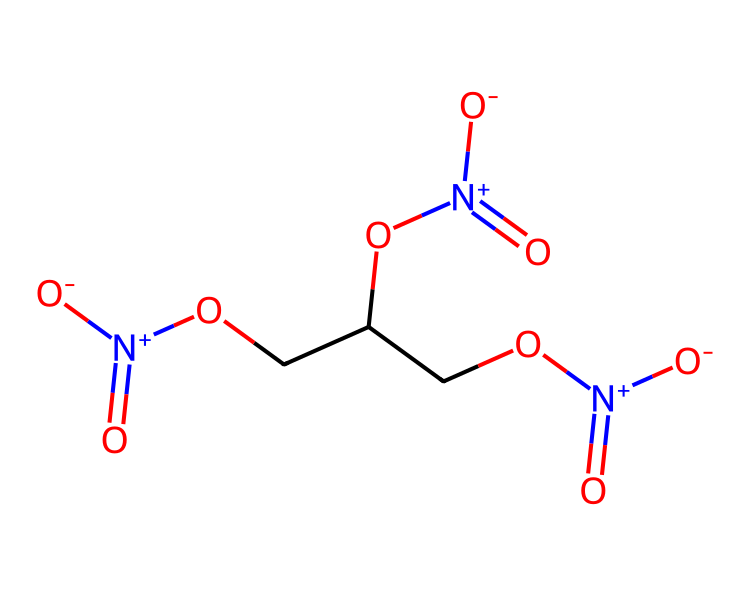What is the molecular formula of nitroglycerin? To find the molecular formula, we count the types and numbers of atoms in the chemical structure. The SMILES representation shows three carbon (C) atoms, five oxygen (O) atoms, and five hydrogen (H) atoms, leading us to the molecular formula C3H5N3O9.
Answer: C3H5N3O9 How many nitrogen atoms are present in nitroglycerin? By examining the structure in the SMILES notation, we can identify that there are three nitrogen (N) atoms attached within the compound.
Answer: 3 What functional groups are present in nitroglycerin? The SMILES representation indicates the presence of nitrate groups (NO2) attached to the structure, specifically indicated by the nitrogen atoms bonded to three oxygen atoms each.
Answer: nitrate groups Why is nitroglycerin considered an explosive compound? Nitroglycerin contains nitrate functional groups that can rapidly decompose and release gas when initiated by heat or shock, leading to an explosion. This can be deduced from the multiple N-O bonds that provide instability under certain conditions.
Answer: instability What is the total number of bonds in the nitroglycerin structure? To determine the total number of bonds, we need to look at the connections between atoms in the chemical structure. The molecule has 12 bonds in total, which includes single and double bonds.
Answer: 12 Which part of the structure contributes to the explosive properties of nitroglycerin? The three nitrate groups (which can be found at the end of the carbon backbone in the SMILES format) are key contributors to the explosive properties, as their ability to release oxygen and create pressure leads to detonation.
Answer: nitrate groups 